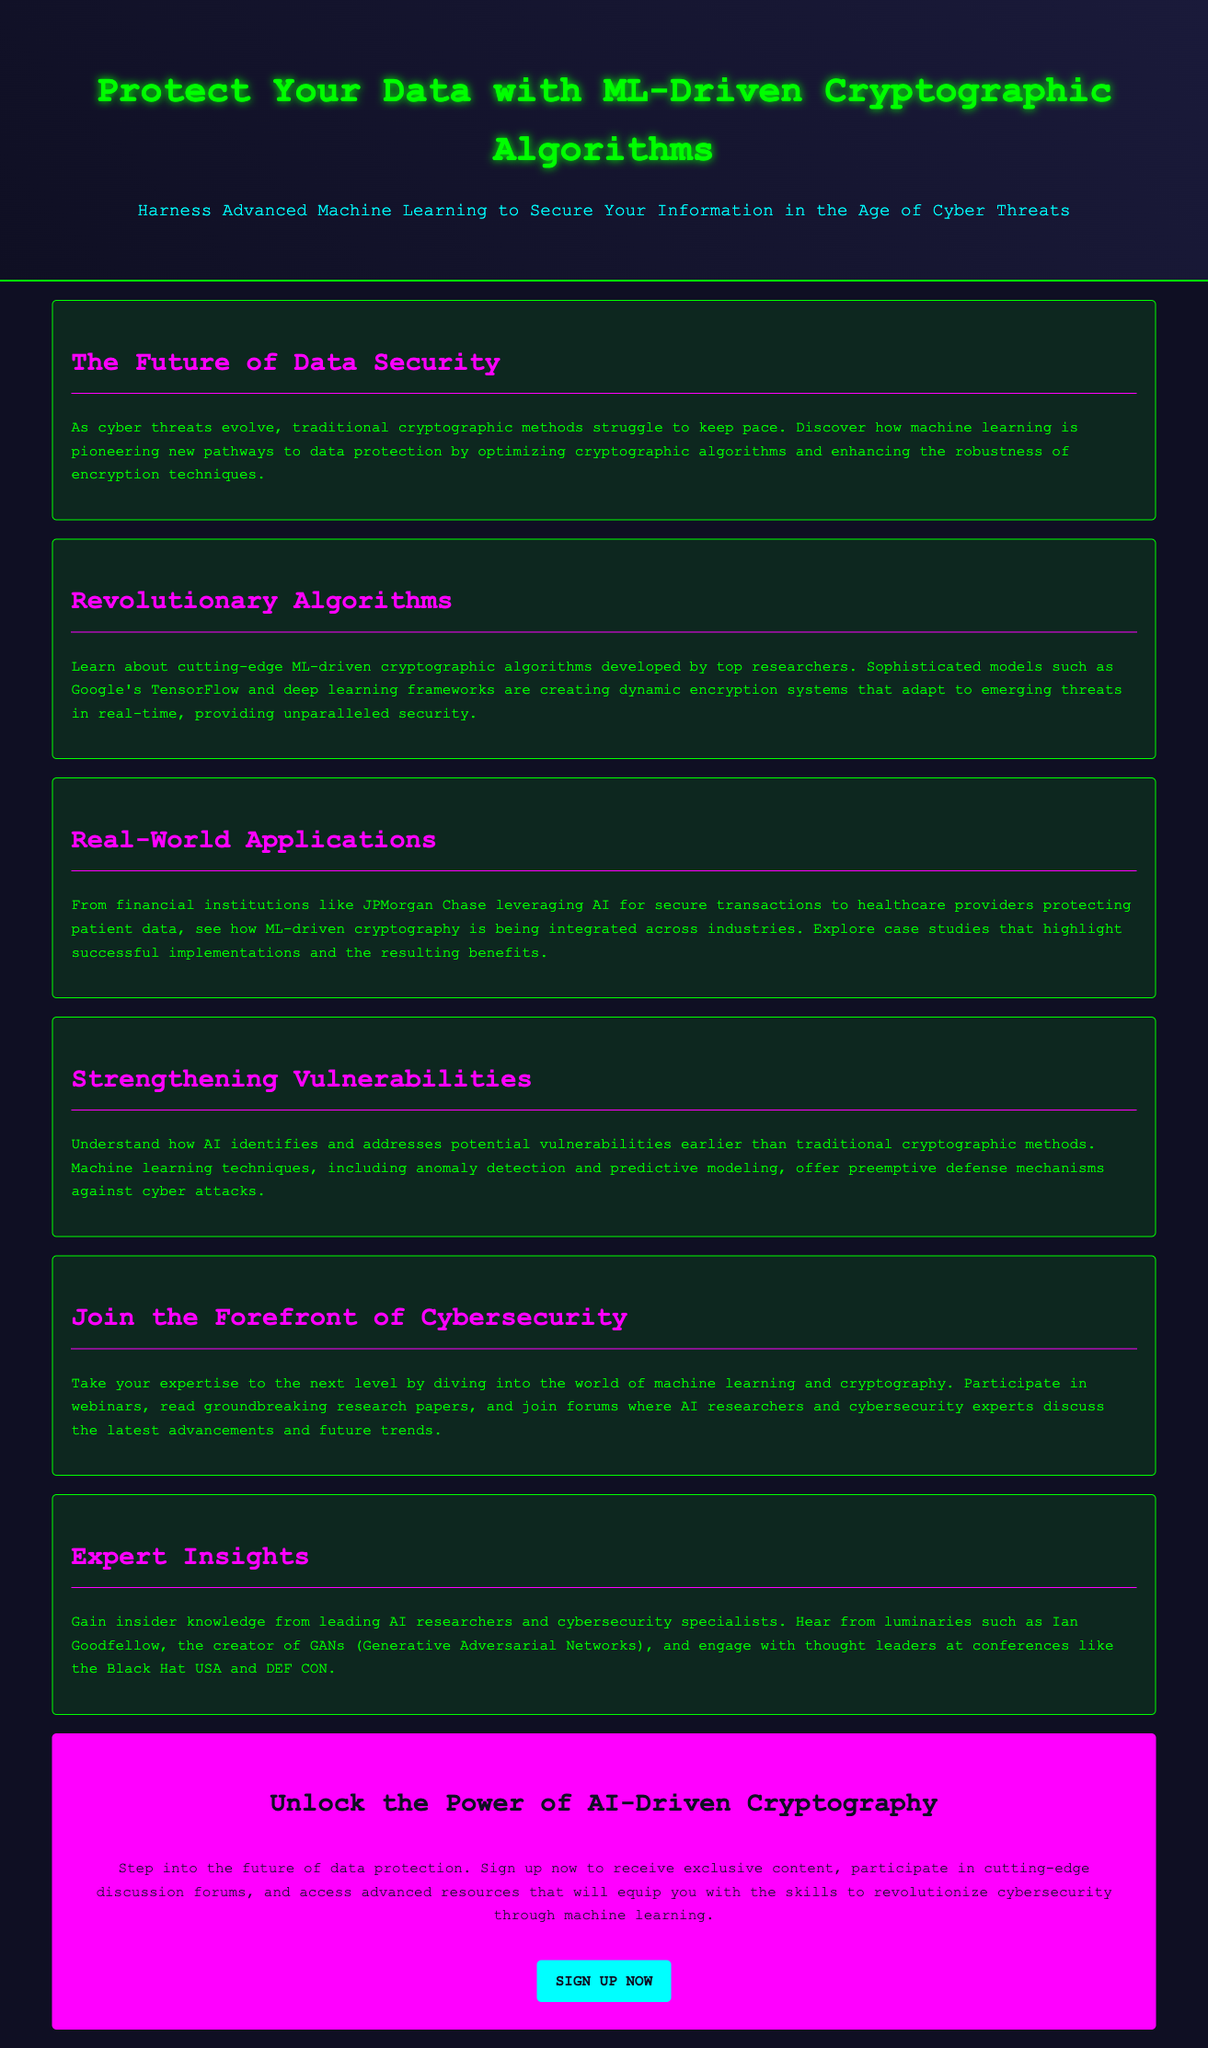What is the main topic of the advertisement? The main topic is centered around utilizing machine learning for data protection through cryptographic algorithms.
Answer: ML-Driven Cryptographic Algorithms What is the subheadline of the document? The subheadline provides a brief description of the advertisement's focus on data security with machine learning.
Answer: Harness Advanced Machine Learning to Secure Your Information in the Age of Cyber Threats Which frameworks are mentioned for developing cryptographic algorithms? The advertisement lists advanced frameworks used in ML-driven cryptographic algorithm development.
Answer: Google's TensorFlow What industry does JPMorgan Chase belong to in the context of this advertisement? The advertisement references JPMorgan Chase as an example representing a specific sector utilizing AI in security.
Answer: Financial institutions What does machine learning offer against potential vulnerabilities? The advertisement states a significant advantage of machine learning techniques in cybersecurity.
Answer: Preemptive defense mechanisms What type of resources can you access by signing up? The advertisement mentions various types of content and activities available to participants who sign up.
Answer: Exclusive content Who is mentioned as a leading figure in AI research? The advertisement highlights an influential individual in AI and their contributions.
Answer: Ian Goodfellow Which conferences are referenced for gaining insights into AI and cybersecurity? The advertisement names specific events where experts discuss advancements in the field.
Answer: Black Hat USA and DEF CON 